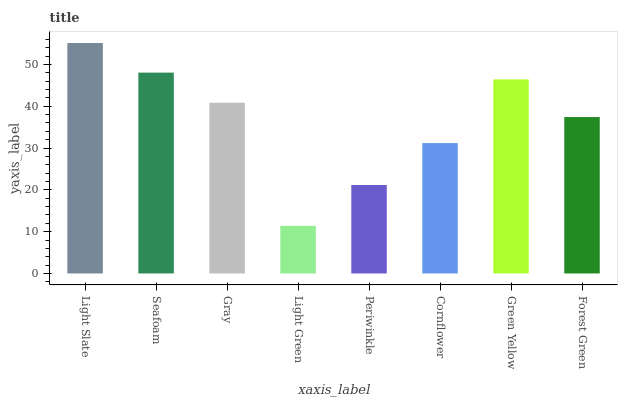Is Light Green the minimum?
Answer yes or no. Yes. Is Light Slate the maximum?
Answer yes or no. Yes. Is Seafoam the minimum?
Answer yes or no. No. Is Seafoam the maximum?
Answer yes or no. No. Is Light Slate greater than Seafoam?
Answer yes or no. Yes. Is Seafoam less than Light Slate?
Answer yes or no. Yes. Is Seafoam greater than Light Slate?
Answer yes or no. No. Is Light Slate less than Seafoam?
Answer yes or no. No. Is Gray the high median?
Answer yes or no. Yes. Is Forest Green the low median?
Answer yes or no. Yes. Is Green Yellow the high median?
Answer yes or no. No. Is Light Green the low median?
Answer yes or no. No. 